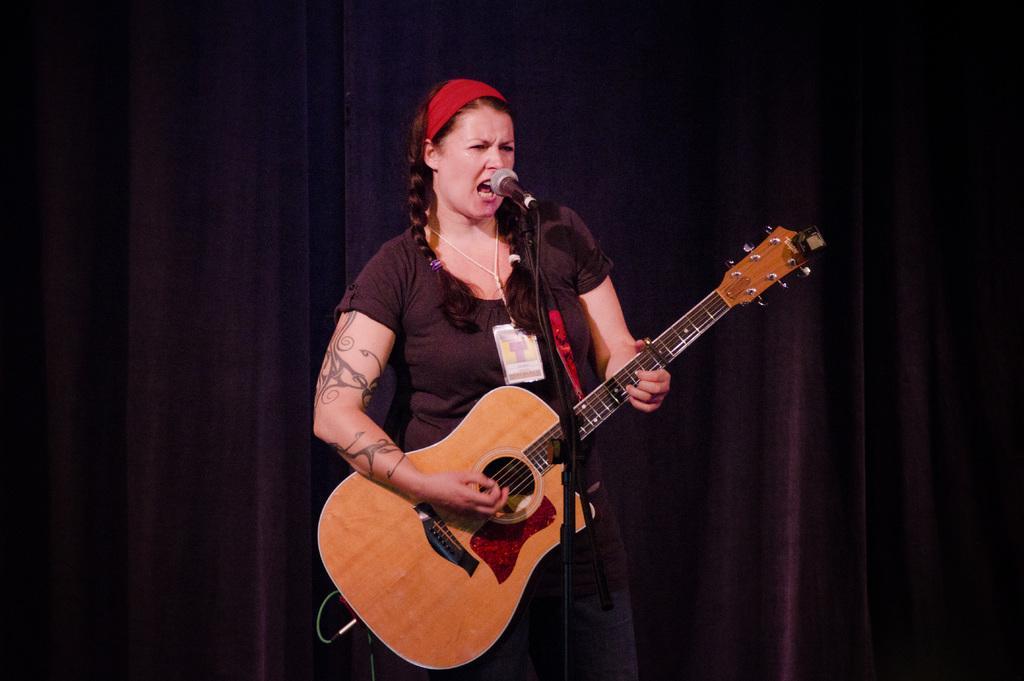Could you give a brief overview of what you see in this image? In this image there is a woman standing and playing a guitar and singing a song in the microphone and the background there is a curtain. 